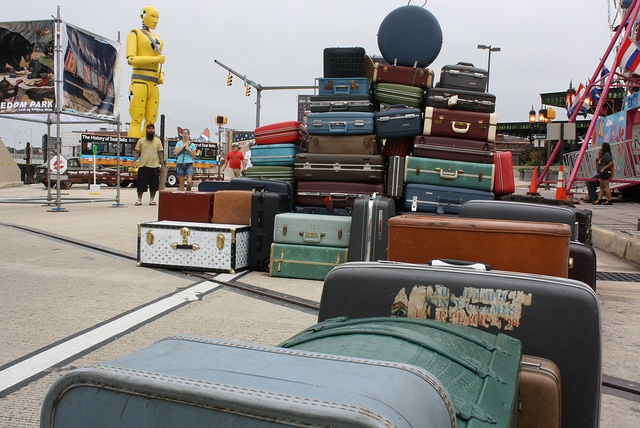Describe the objects in this image and their specific colors. I can see suitcase in lightgray, black, gray, darkgray, and blue tones, suitcase in lightgray, darkgray, purple, and black tones, suitcase in lightgray, black, gray, and darkgray tones, suitcase in lightgray, maroon, brown, black, and gray tones, and bus in lightgray, black, gray, maroon, and darkgray tones in this image. 